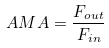<formula> <loc_0><loc_0><loc_500><loc_500>A M A = \frac { F _ { o u t } } { F _ { i n } }</formula> 